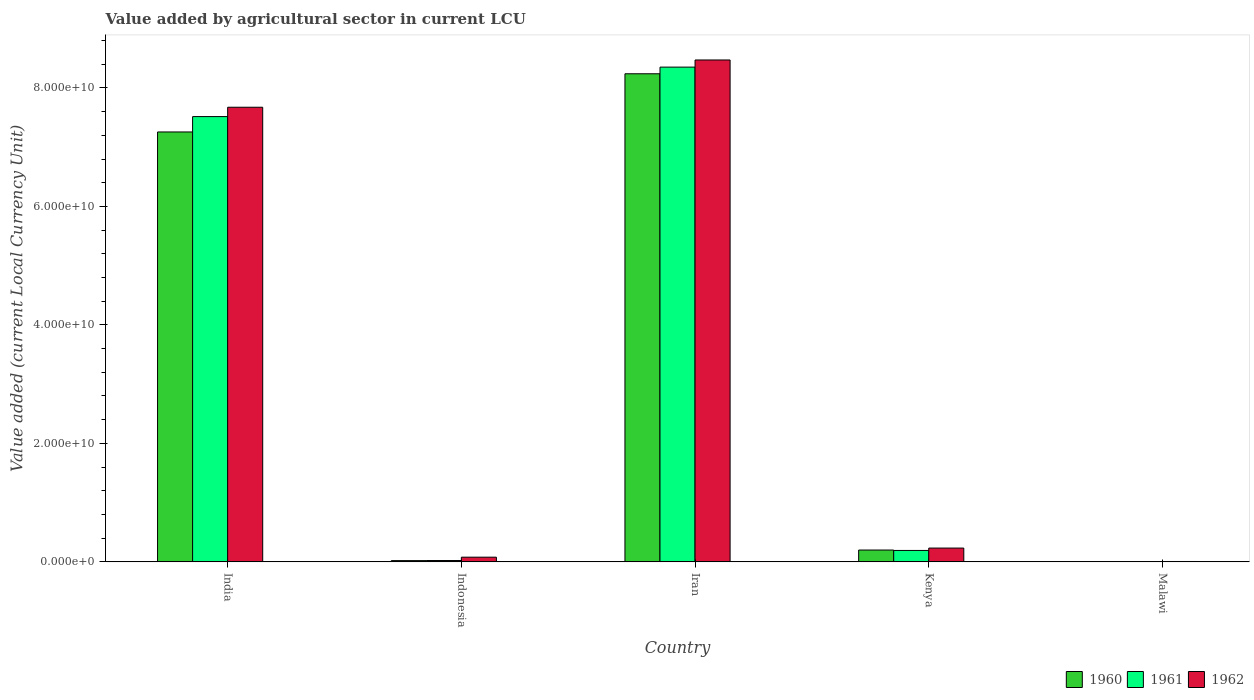What is the label of the 2nd group of bars from the left?
Ensure brevity in your answer.  Indonesia. In how many cases, is the number of bars for a given country not equal to the number of legend labels?
Ensure brevity in your answer.  0. What is the value added by agricultural sector in 1960 in Malawi?
Your response must be concise. 5.63e+07. Across all countries, what is the maximum value added by agricultural sector in 1960?
Provide a succinct answer. 8.24e+1. Across all countries, what is the minimum value added by agricultural sector in 1961?
Your answer should be very brief. 6.06e+07. In which country was the value added by agricultural sector in 1960 maximum?
Keep it short and to the point. Iran. In which country was the value added by agricultural sector in 1961 minimum?
Ensure brevity in your answer.  Malawi. What is the total value added by agricultural sector in 1961 in the graph?
Your answer should be very brief. 1.61e+11. What is the difference between the value added by agricultural sector in 1962 in India and that in Indonesia?
Offer a very short reply. 7.59e+1. What is the difference between the value added by agricultural sector in 1960 in Indonesia and the value added by agricultural sector in 1961 in Kenya?
Your answer should be compact. -1.72e+09. What is the average value added by agricultural sector in 1962 per country?
Ensure brevity in your answer.  3.29e+1. What is the difference between the value added by agricultural sector of/in 1961 and value added by agricultural sector of/in 1960 in Indonesia?
Your response must be concise. 1.50e+07. In how many countries, is the value added by agricultural sector in 1962 greater than 64000000000 LCU?
Your answer should be very brief. 2. What is the ratio of the value added by agricultural sector in 1960 in Indonesia to that in Iran?
Your response must be concise. 0. Is the difference between the value added by agricultural sector in 1961 in Kenya and Malawi greater than the difference between the value added by agricultural sector in 1960 in Kenya and Malawi?
Offer a very short reply. No. What is the difference between the highest and the second highest value added by agricultural sector in 1962?
Your response must be concise. -7.98e+09. What is the difference between the highest and the lowest value added by agricultural sector in 1962?
Provide a succinct answer. 8.47e+1. In how many countries, is the value added by agricultural sector in 1961 greater than the average value added by agricultural sector in 1961 taken over all countries?
Provide a succinct answer. 2. What does the 2nd bar from the right in Kenya represents?
Your response must be concise. 1961. How many bars are there?
Offer a terse response. 15. Are the values on the major ticks of Y-axis written in scientific E-notation?
Your answer should be very brief. Yes. Does the graph contain any zero values?
Keep it short and to the point. No. Does the graph contain grids?
Keep it short and to the point. No. Where does the legend appear in the graph?
Your response must be concise. Bottom right. How many legend labels are there?
Your response must be concise. 3. How are the legend labels stacked?
Provide a succinct answer. Horizontal. What is the title of the graph?
Offer a terse response. Value added by agricultural sector in current LCU. Does "1986" appear as one of the legend labels in the graph?
Offer a terse response. No. What is the label or title of the X-axis?
Keep it short and to the point. Country. What is the label or title of the Y-axis?
Make the answer very short. Value added (current Local Currency Unit). What is the Value added (current Local Currency Unit) of 1960 in India?
Ensure brevity in your answer.  7.26e+1. What is the Value added (current Local Currency Unit) of 1961 in India?
Your response must be concise. 7.52e+1. What is the Value added (current Local Currency Unit) of 1962 in India?
Give a very brief answer. 7.67e+1. What is the Value added (current Local Currency Unit) in 1960 in Indonesia?
Your answer should be compact. 2.12e+08. What is the Value added (current Local Currency Unit) in 1961 in Indonesia?
Your answer should be compact. 2.27e+08. What is the Value added (current Local Currency Unit) in 1962 in Indonesia?
Your response must be concise. 7.93e+08. What is the Value added (current Local Currency Unit) in 1960 in Iran?
Provide a short and direct response. 8.24e+1. What is the Value added (current Local Currency Unit) of 1961 in Iran?
Make the answer very short. 8.35e+1. What is the Value added (current Local Currency Unit) in 1962 in Iran?
Offer a terse response. 8.47e+1. What is the Value added (current Local Currency Unit) of 1960 in Kenya?
Make the answer very short. 2.00e+09. What is the Value added (current Local Currency Unit) of 1961 in Kenya?
Keep it short and to the point. 1.93e+09. What is the Value added (current Local Currency Unit) in 1962 in Kenya?
Make the answer very short. 2.33e+09. What is the Value added (current Local Currency Unit) of 1960 in Malawi?
Your response must be concise. 5.63e+07. What is the Value added (current Local Currency Unit) of 1961 in Malawi?
Offer a terse response. 6.06e+07. What is the Value added (current Local Currency Unit) of 1962 in Malawi?
Give a very brief answer. 6.36e+07. Across all countries, what is the maximum Value added (current Local Currency Unit) in 1960?
Your answer should be compact. 8.24e+1. Across all countries, what is the maximum Value added (current Local Currency Unit) in 1961?
Your answer should be very brief. 8.35e+1. Across all countries, what is the maximum Value added (current Local Currency Unit) of 1962?
Offer a very short reply. 8.47e+1. Across all countries, what is the minimum Value added (current Local Currency Unit) of 1960?
Provide a succinct answer. 5.63e+07. Across all countries, what is the minimum Value added (current Local Currency Unit) in 1961?
Your answer should be very brief. 6.06e+07. Across all countries, what is the minimum Value added (current Local Currency Unit) in 1962?
Offer a terse response. 6.36e+07. What is the total Value added (current Local Currency Unit) in 1960 in the graph?
Your answer should be very brief. 1.57e+11. What is the total Value added (current Local Currency Unit) in 1961 in the graph?
Give a very brief answer. 1.61e+11. What is the total Value added (current Local Currency Unit) of 1962 in the graph?
Your answer should be very brief. 1.65e+11. What is the difference between the Value added (current Local Currency Unit) of 1960 in India and that in Indonesia?
Give a very brief answer. 7.24e+1. What is the difference between the Value added (current Local Currency Unit) of 1961 in India and that in Indonesia?
Your response must be concise. 7.49e+1. What is the difference between the Value added (current Local Currency Unit) in 1962 in India and that in Indonesia?
Ensure brevity in your answer.  7.59e+1. What is the difference between the Value added (current Local Currency Unit) in 1960 in India and that in Iran?
Your answer should be compact. -9.82e+09. What is the difference between the Value added (current Local Currency Unit) of 1961 in India and that in Iran?
Offer a terse response. -8.35e+09. What is the difference between the Value added (current Local Currency Unit) of 1962 in India and that in Iran?
Offer a very short reply. -7.98e+09. What is the difference between the Value added (current Local Currency Unit) in 1960 in India and that in Kenya?
Offer a very short reply. 7.06e+1. What is the difference between the Value added (current Local Currency Unit) of 1961 in India and that in Kenya?
Keep it short and to the point. 7.32e+1. What is the difference between the Value added (current Local Currency Unit) in 1962 in India and that in Kenya?
Your answer should be very brief. 7.44e+1. What is the difference between the Value added (current Local Currency Unit) in 1960 in India and that in Malawi?
Give a very brief answer. 7.25e+1. What is the difference between the Value added (current Local Currency Unit) in 1961 in India and that in Malawi?
Give a very brief answer. 7.51e+1. What is the difference between the Value added (current Local Currency Unit) in 1962 in India and that in Malawi?
Give a very brief answer. 7.67e+1. What is the difference between the Value added (current Local Currency Unit) of 1960 in Indonesia and that in Iran?
Provide a succinct answer. -8.22e+1. What is the difference between the Value added (current Local Currency Unit) of 1961 in Indonesia and that in Iran?
Your response must be concise. -8.33e+1. What is the difference between the Value added (current Local Currency Unit) in 1962 in Indonesia and that in Iran?
Ensure brevity in your answer.  -8.39e+1. What is the difference between the Value added (current Local Currency Unit) of 1960 in Indonesia and that in Kenya?
Your answer should be very brief. -1.79e+09. What is the difference between the Value added (current Local Currency Unit) of 1961 in Indonesia and that in Kenya?
Your answer should be compact. -1.70e+09. What is the difference between the Value added (current Local Currency Unit) of 1962 in Indonesia and that in Kenya?
Ensure brevity in your answer.  -1.54e+09. What is the difference between the Value added (current Local Currency Unit) in 1960 in Indonesia and that in Malawi?
Give a very brief answer. 1.56e+08. What is the difference between the Value added (current Local Currency Unit) of 1961 in Indonesia and that in Malawi?
Offer a terse response. 1.66e+08. What is the difference between the Value added (current Local Currency Unit) of 1962 in Indonesia and that in Malawi?
Give a very brief answer. 7.29e+08. What is the difference between the Value added (current Local Currency Unit) in 1960 in Iran and that in Kenya?
Provide a succinct answer. 8.04e+1. What is the difference between the Value added (current Local Currency Unit) in 1961 in Iran and that in Kenya?
Your answer should be compact. 8.16e+1. What is the difference between the Value added (current Local Currency Unit) in 1962 in Iran and that in Kenya?
Give a very brief answer. 8.24e+1. What is the difference between the Value added (current Local Currency Unit) in 1960 in Iran and that in Malawi?
Give a very brief answer. 8.23e+1. What is the difference between the Value added (current Local Currency Unit) in 1961 in Iran and that in Malawi?
Make the answer very short. 8.34e+1. What is the difference between the Value added (current Local Currency Unit) in 1962 in Iran and that in Malawi?
Give a very brief answer. 8.47e+1. What is the difference between the Value added (current Local Currency Unit) in 1960 in Kenya and that in Malawi?
Your answer should be compact. 1.94e+09. What is the difference between the Value added (current Local Currency Unit) of 1961 in Kenya and that in Malawi?
Offer a terse response. 1.87e+09. What is the difference between the Value added (current Local Currency Unit) of 1962 in Kenya and that in Malawi?
Ensure brevity in your answer.  2.27e+09. What is the difference between the Value added (current Local Currency Unit) in 1960 in India and the Value added (current Local Currency Unit) in 1961 in Indonesia?
Make the answer very short. 7.23e+1. What is the difference between the Value added (current Local Currency Unit) in 1960 in India and the Value added (current Local Currency Unit) in 1962 in Indonesia?
Your answer should be very brief. 7.18e+1. What is the difference between the Value added (current Local Currency Unit) of 1961 in India and the Value added (current Local Currency Unit) of 1962 in Indonesia?
Keep it short and to the point. 7.44e+1. What is the difference between the Value added (current Local Currency Unit) of 1960 in India and the Value added (current Local Currency Unit) of 1961 in Iran?
Offer a very short reply. -1.09e+1. What is the difference between the Value added (current Local Currency Unit) of 1960 in India and the Value added (current Local Currency Unit) of 1962 in Iran?
Offer a very short reply. -1.22e+1. What is the difference between the Value added (current Local Currency Unit) in 1961 in India and the Value added (current Local Currency Unit) in 1962 in Iran?
Offer a terse response. -9.56e+09. What is the difference between the Value added (current Local Currency Unit) in 1960 in India and the Value added (current Local Currency Unit) in 1961 in Kenya?
Your response must be concise. 7.06e+1. What is the difference between the Value added (current Local Currency Unit) in 1960 in India and the Value added (current Local Currency Unit) in 1962 in Kenya?
Give a very brief answer. 7.02e+1. What is the difference between the Value added (current Local Currency Unit) of 1961 in India and the Value added (current Local Currency Unit) of 1962 in Kenya?
Give a very brief answer. 7.28e+1. What is the difference between the Value added (current Local Currency Unit) in 1960 in India and the Value added (current Local Currency Unit) in 1961 in Malawi?
Your response must be concise. 7.25e+1. What is the difference between the Value added (current Local Currency Unit) of 1960 in India and the Value added (current Local Currency Unit) of 1962 in Malawi?
Offer a very short reply. 7.25e+1. What is the difference between the Value added (current Local Currency Unit) of 1961 in India and the Value added (current Local Currency Unit) of 1962 in Malawi?
Provide a short and direct response. 7.51e+1. What is the difference between the Value added (current Local Currency Unit) in 1960 in Indonesia and the Value added (current Local Currency Unit) in 1961 in Iran?
Your answer should be compact. -8.33e+1. What is the difference between the Value added (current Local Currency Unit) in 1960 in Indonesia and the Value added (current Local Currency Unit) in 1962 in Iran?
Your answer should be compact. -8.45e+1. What is the difference between the Value added (current Local Currency Unit) of 1961 in Indonesia and the Value added (current Local Currency Unit) of 1962 in Iran?
Make the answer very short. -8.45e+1. What is the difference between the Value added (current Local Currency Unit) in 1960 in Indonesia and the Value added (current Local Currency Unit) in 1961 in Kenya?
Your answer should be compact. -1.72e+09. What is the difference between the Value added (current Local Currency Unit) in 1960 in Indonesia and the Value added (current Local Currency Unit) in 1962 in Kenya?
Provide a succinct answer. -2.12e+09. What is the difference between the Value added (current Local Currency Unit) of 1961 in Indonesia and the Value added (current Local Currency Unit) of 1962 in Kenya?
Provide a short and direct response. -2.10e+09. What is the difference between the Value added (current Local Currency Unit) of 1960 in Indonesia and the Value added (current Local Currency Unit) of 1961 in Malawi?
Give a very brief answer. 1.51e+08. What is the difference between the Value added (current Local Currency Unit) in 1960 in Indonesia and the Value added (current Local Currency Unit) in 1962 in Malawi?
Give a very brief answer. 1.48e+08. What is the difference between the Value added (current Local Currency Unit) in 1961 in Indonesia and the Value added (current Local Currency Unit) in 1962 in Malawi?
Offer a very short reply. 1.63e+08. What is the difference between the Value added (current Local Currency Unit) in 1960 in Iran and the Value added (current Local Currency Unit) in 1961 in Kenya?
Make the answer very short. 8.05e+1. What is the difference between the Value added (current Local Currency Unit) of 1960 in Iran and the Value added (current Local Currency Unit) of 1962 in Kenya?
Provide a succinct answer. 8.01e+1. What is the difference between the Value added (current Local Currency Unit) in 1961 in Iran and the Value added (current Local Currency Unit) in 1962 in Kenya?
Provide a short and direct response. 8.12e+1. What is the difference between the Value added (current Local Currency Unit) in 1960 in Iran and the Value added (current Local Currency Unit) in 1961 in Malawi?
Provide a short and direct response. 8.23e+1. What is the difference between the Value added (current Local Currency Unit) of 1960 in Iran and the Value added (current Local Currency Unit) of 1962 in Malawi?
Offer a terse response. 8.23e+1. What is the difference between the Value added (current Local Currency Unit) of 1961 in Iran and the Value added (current Local Currency Unit) of 1962 in Malawi?
Your answer should be very brief. 8.34e+1. What is the difference between the Value added (current Local Currency Unit) of 1960 in Kenya and the Value added (current Local Currency Unit) of 1961 in Malawi?
Your answer should be compact. 1.94e+09. What is the difference between the Value added (current Local Currency Unit) in 1960 in Kenya and the Value added (current Local Currency Unit) in 1962 in Malawi?
Your answer should be very brief. 1.93e+09. What is the difference between the Value added (current Local Currency Unit) of 1961 in Kenya and the Value added (current Local Currency Unit) of 1962 in Malawi?
Your answer should be compact. 1.87e+09. What is the average Value added (current Local Currency Unit) in 1960 per country?
Keep it short and to the point. 3.14e+1. What is the average Value added (current Local Currency Unit) in 1961 per country?
Keep it short and to the point. 3.22e+1. What is the average Value added (current Local Currency Unit) of 1962 per country?
Your response must be concise. 3.29e+1. What is the difference between the Value added (current Local Currency Unit) in 1960 and Value added (current Local Currency Unit) in 1961 in India?
Your answer should be compact. -2.59e+09. What is the difference between the Value added (current Local Currency Unit) of 1960 and Value added (current Local Currency Unit) of 1962 in India?
Make the answer very short. -4.17e+09. What is the difference between the Value added (current Local Currency Unit) in 1961 and Value added (current Local Currency Unit) in 1962 in India?
Make the answer very short. -1.58e+09. What is the difference between the Value added (current Local Currency Unit) of 1960 and Value added (current Local Currency Unit) of 1961 in Indonesia?
Your answer should be very brief. -1.50e+07. What is the difference between the Value added (current Local Currency Unit) of 1960 and Value added (current Local Currency Unit) of 1962 in Indonesia?
Your answer should be very brief. -5.81e+08. What is the difference between the Value added (current Local Currency Unit) of 1961 and Value added (current Local Currency Unit) of 1962 in Indonesia?
Provide a short and direct response. -5.66e+08. What is the difference between the Value added (current Local Currency Unit) of 1960 and Value added (current Local Currency Unit) of 1961 in Iran?
Your response must be concise. -1.12e+09. What is the difference between the Value added (current Local Currency Unit) of 1960 and Value added (current Local Currency Unit) of 1962 in Iran?
Make the answer very short. -2.33e+09. What is the difference between the Value added (current Local Currency Unit) in 1961 and Value added (current Local Currency Unit) in 1962 in Iran?
Your answer should be very brief. -1.21e+09. What is the difference between the Value added (current Local Currency Unit) in 1960 and Value added (current Local Currency Unit) in 1961 in Kenya?
Keep it short and to the point. 6.79e+07. What is the difference between the Value added (current Local Currency Unit) of 1960 and Value added (current Local Currency Unit) of 1962 in Kenya?
Offer a very short reply. -3.32e+08. What is the difference between the Value added (current Local Currency Unit) in 1961 and Value added (current Local Currency Unit) in 1962 in Kenya?
Your answer should be compact. -4.00e+08. What is the difference between the Value added (current Local Currency Unit) of 1960 and Value added (current Local Currency Unit) of 1961 in Malawi?
Offer a terse response. -4.30e+06. What is the difference between the Value added (current Local Currency Unit) of 1960 and Value added (current Local Currency Unit) of 1962 in Malawi?
Make the answer very short. -7.30e+06. What is the ratio of the Value added (current Local Currency Unit) of 1960 in India to that in Indonesia?
Your response must be concise. 342.29. What is the ratio of the Value added (current Local Currency Unit) in 1961 in India to that in Indonesia?
Keep it short and to the point. 331.1. What is the ratio of the Value added (current Local Currency Unit) in 1962 in India to that in Indonesia?
Your answer should be compact. 96.77. What is the ratio of the Value added (current Local Currency Unit) in 1960 in India to that in Iran?
Keep it short and to the point. 0.88. What is the ratio of the Value added (current Local Currency Unit) of 1962 in India to that in Iran?
Keep it short and to the point. 0.91. What is the ratio of the Value added (current Local Currency Unit) of 1960 in India to that in Kenya?
Offer a terse response. 36.32. What is the ratio of the Value added (current Local Currency Unit) of 1961 in India to that in Kenya?
Offer a terse response. 38.94. What is the ratio of the Value added (current Local Currency Unit) in 1962 in India to that in Kenya?
Offer a very short reply. 32.94. What is the ratio of the Value added (current Local Currency Unit) in 1960 in India to that in Malawi?
Your answer should be very brief. 1288.89. What is the ratio of the Value added (current Local Currency Unit) of 1961 in India to that in Malawi?
Ensure brevity in your answer.  1240.24. What is the ratio of the Value added (current Local Currency Unit) in 1962 in India to that in Malawi?
Offer a terse response. 1206.57. What is the ratio of the Value added (current Local Currency Unit) in 1960 in Indonesia to that in Iran?
Make the answer very short. 0. What is the ratio of the Value added (current Local Currency Unit) in 1961 in Indonesia to that in Iran?
Offer a terse response. 0. What is the ratio of the Value added (current Local Currency Unit) in 1962 in Indonesia to that in Iran?
Ensure brevity in your answer.  0.01. What is the ratio of the Value added (current Local Currency Unit) in 1960 in Indonesia to that in Kenya?
Provide a short and direct response. 0.11. What is the ratio of the Value added (current Local Currency Unit) of 1961 in Indonesia to that in Kenya?
Offer a terse response. 0.12. What is the ratio of the Value added (current Local Currency Unit) of 1962 in Indonesia to that in Kenya?
Your answer should be compact. 0.34. What is the ratio of the Value added (current Local Currency Unit) of 1960 in Indonesia to that in Malawi?
Provide a short and direct response. 3.77. What is the ratio of the Value added (current Local Currency Unit) in 1961 in Indonesia to that in Malawi?
Provide a short and direct response. 3.75. What is the ratio of the Value added (current Local Currency Unit) in 1962 in Indonesia to that in Malawi?
Give a very brief answer. 12.47. What is the ratio of the Value added (current Local Currency Unit) of 1960 in Iran to that in Kenya?
Make the answer very short. 41.24. What is the ratio of the Value added (current Local Currency Unit) in 1961 in Iran to that in Kenya?
Your response must be concise. 43.27. What is the ratio of the Value added (current Local Currency Unit) of 1962 in Iran to that in Kenya?
Ensure brevity in your answer.  36.36. What is the ratio of the Value added (current Local Currency Unit) in 1960 in Iran to that in Malawi?
Ensure brevity in your answer.  1463.34. What is the ratio of the Value added (current Local Currency Unit) in 1961 in Iran to that in Malawi?
Your answer should be compact. 1378.03. What is the ratio of the Value added (current Local Currency Unit) of 1962 in Iran to that in Malawi?
Offer a terse response. 1332.01. What is the ratio of the Value added (current Local Currency Unit) of 1960 in Kenya to that in Malawi?
Provide a succinct answer. 35.48. What is the ratio of the Value added (current Local Currency Unit) of 1961 in Kenya to that in Malawi?
Ensure brevity in your answer.  31.85. What is the ratio of the Value added (current Local Currency Unit) of 1962 in Kenya to that in Malawi?
Make the answer very short. 36.63. What is the difference between the highest and the second highest Value added (current Local Currency Unit) in 1960?
Your response must be concise. 9.82e+09. What is the difference between the highest and the second highest Value added (current Local Currency Unit) in 1961?
Your answer should be very brief. 8.35e+09. What is the difference between the highest and the second highest Value added (current Local Currency Unit) of 1962?
Give a very brief answer. 7.98e+09. What is the difference between the highest and the lowest Value added (current Local Currency Unit) of 1960?
Your answer should be compact. 8.23e+1. What is the difference between the highest and the lowest Value added (current Local Currency Unit) in 1961?
Ensure brevity in your answer.  8.34e+1. What is the difference between the highest and the lowest Value added (current Local Currency Unit) of 1962?
Your answer should be very brief. 8.47e+1. 